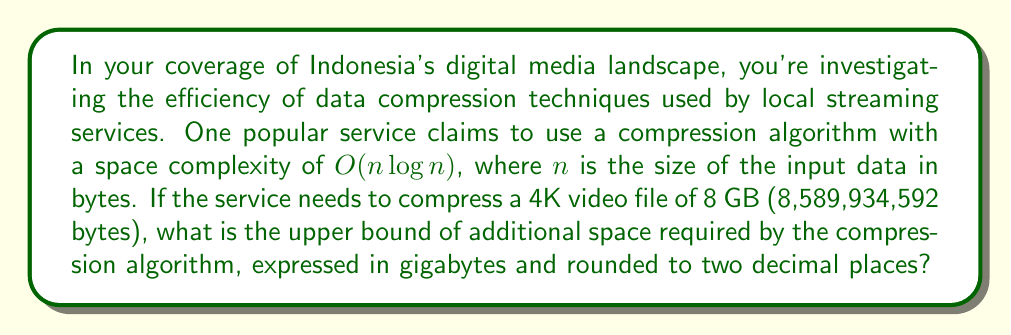Help me with this question. To solve this problem, we need to follow these steps:

1. Understand the space complexity:
   The algorithm has a space complexity of $O(n \log n)$, which means the additional space required is proportional to $n \log n$, where $n$ is the input size.

2. Calculate $n \log n$ for the given input size:
   $n = 8,589,934,592$ bytes (8 GB)
   
   $n \log n = 8,589,934,592 \times \log_2(8,589,934,592)$
   
   $\log_2(8,589,934,592) = \log_2(2^{33}) = 33$
   
   $n \log n = 8,589,934,592 \times 33 = 283,467,841,536$ bytes

3. Convert the result to gigabytes:
   $283,467,841,536$ bytes $= \frac{283,467,841,536}{1,073,741,824}$ GB
   $= 263.97$ GB (rounded to two decimal places)

Note that this is an upper bound, as the big O notation represents the worst-case scenario. The actual space used might be less in practice.
Answer: 263.97 GB 